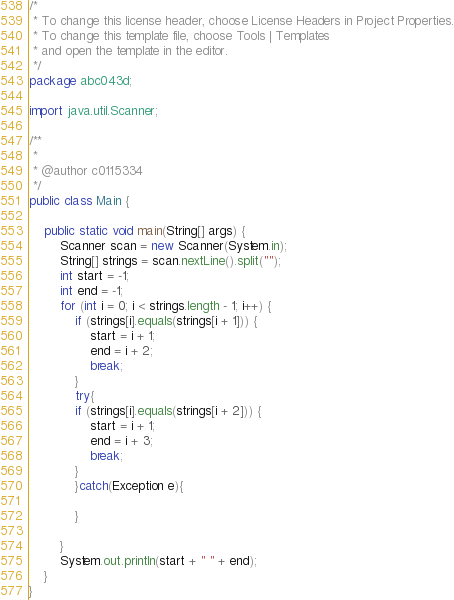Convert code to text. <code><loc_0><loc_0><loc_500><loc_500><_Java_>/*
 * To change this license header, choose License Headers in Project Properties.
 * To change this template file, choose Tools | Templates
 * and open the template in the editor.
 */
package abc043d;

import java.util.Scanner;

/**
 *
 * @author c0115334
 */
public class Main {

    public static void main(String[] args) {
        Scanner scan = new Scanner(System.in);
        String[] strings = scan.nextLine().split("");
        int start = -1;
        int end = -1;
        for (int i = 0; i < strings.length - 1; i++) {
            if (strings[i].equals(strings[i + 1])) {
                start = i + 1;
                end = i + 2;
                break;
            }
            try{
            if (strings[i].equals(strings[i + 2])) {
                start = i + 1;
                end = i + 3;
                break;
            }
            }catch(Exception e){
                
            }

        }
        System.out.println(start + " " + end);
    }
}
</code> 